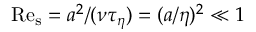<formula> <loc_0><loc_0><loc_500><loc_500>R e _ { s } = a ^ { 2 } / ( \nu \tau _ { \eta } ) = ( a / \eta ) ^ { 2 } \ll 1</formula> 